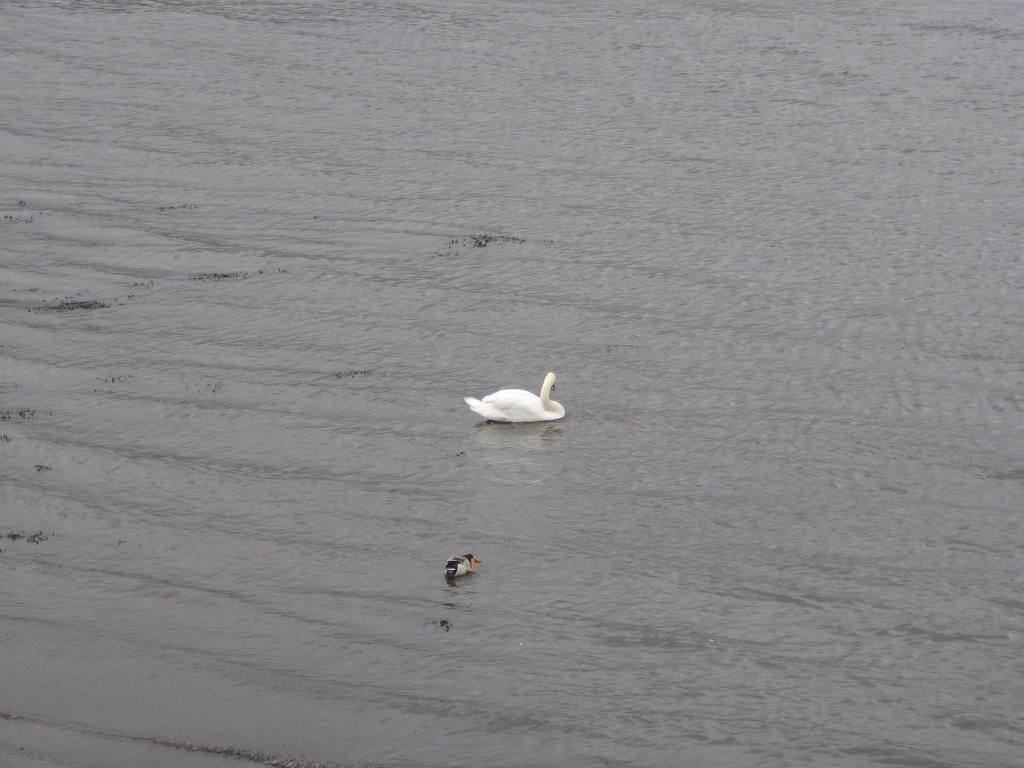What is present in the image? There is water visible in the image, and a swan is in the water. Can you describe the swan in the image? The swan is in the water, and it is likely swimming or floating. How many books can be seen on the swan's back in the image? There are no books present in the image; it only features water and a swan. What type of skirt is the swan wearing in the image? Swans do not wear skirts, as they are birds and not humans. 